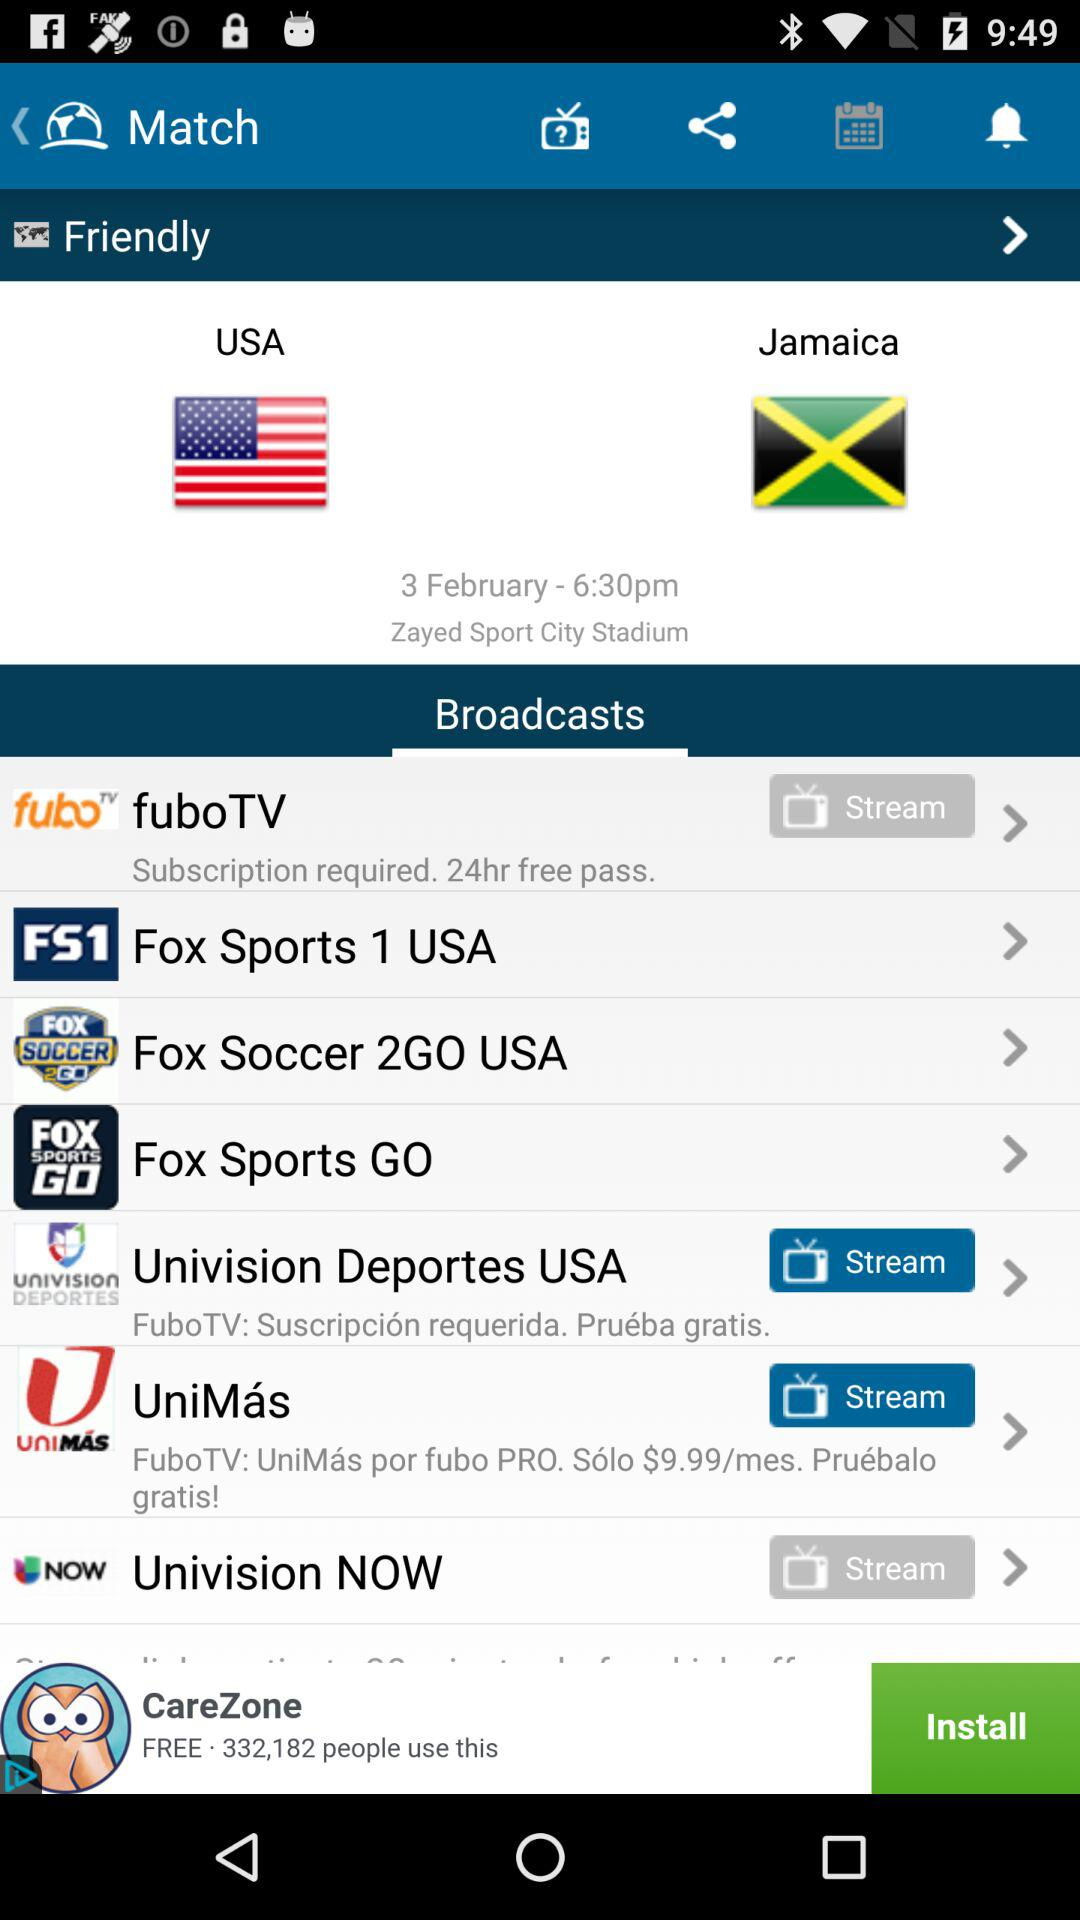How many hours of subscription are required in the "fuboTV" application? There are 24 hours of subscription required in the "fuboTV" application. 